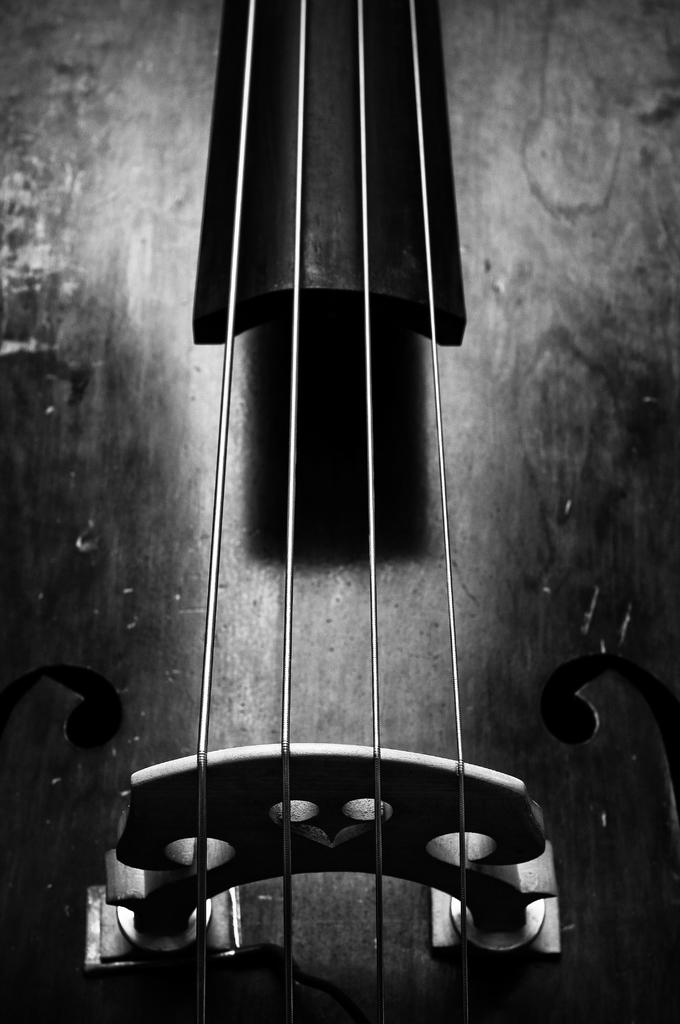What musical instrument is featured in the image? The image features the strings of a guitar. How many apples are hanging from the guitar strings in the image? There are no apples present in the image; it only features the strings of a guitar. What type of pipe can be seen connected to the guitar in the image? There is no pipe connected to the guitar in the image; it only features the strings. 